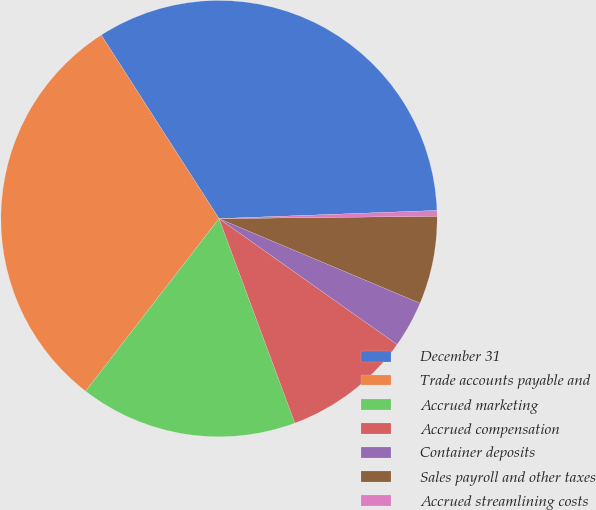Convert chart to OTSL. <chart><loc_0><loc_0><loc_500><loc_500><pie_chart><fcel>December 31<fcel>Trade accounts payable and<fcel>Accrued marketing<fcel>Accrued compensation<fcel>Container deposits<fcel>Sales payroll and other taxes<fcel>Accrued streamlining costs<nl><fcel>33.49%<fcel>30.45%<fcel>16.13%<fcel>9.55%<fcel>3.46%<fcel>6.51%<fcel>0.42%<nl></chart> 